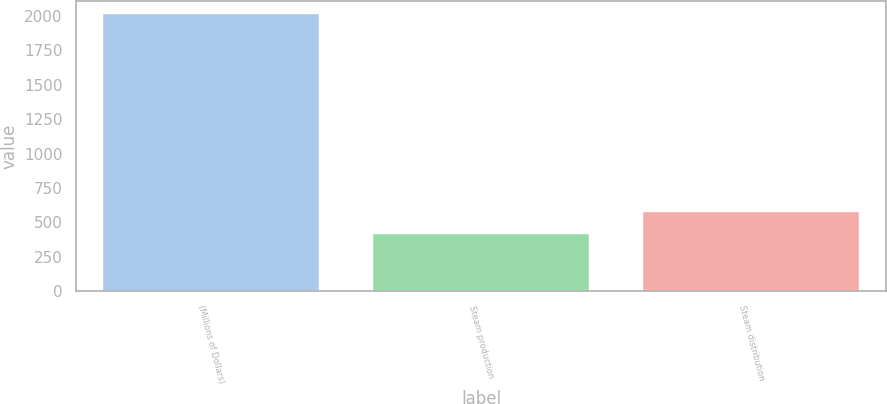<chart> <loc_0><loc_0><loc_500><loc_500><bar_chart><fcel>(Millions of Dollars)<fcel>Steam production<fcel>Steam distribution<nl><fcel>2011<fcel>415<fcel>574.6<nl></chart> 